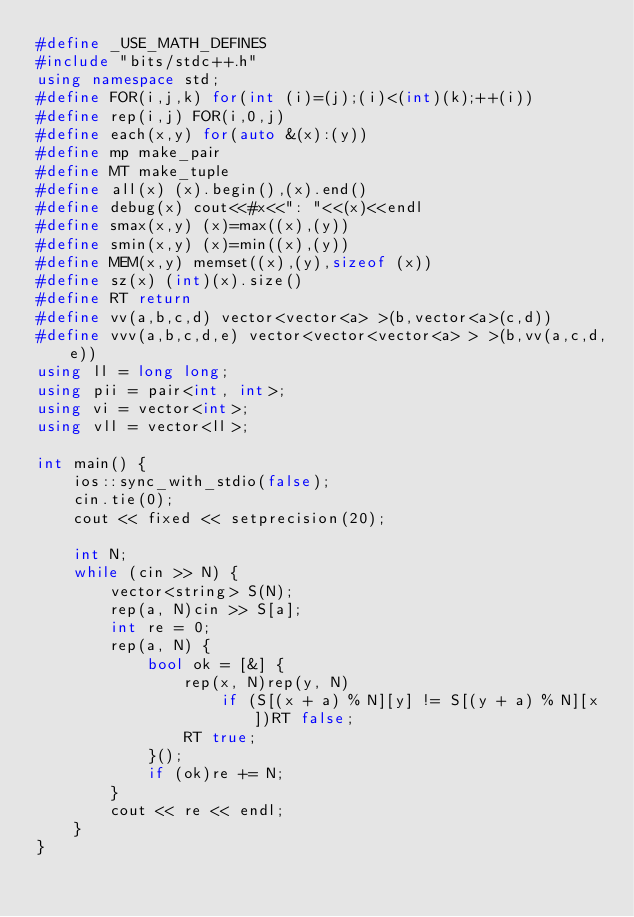Convert code to text. <code><loc_0><loc_0><loc_500><loc_500><_C++_>#define _USE_MATH_DEFINES
#include "bits/stdc++.h"
using namespace std;
#define FOR(i,j,k) for(int (i)=(j);(i)<(int)(k);++(i))
#define rep(i,j) FOR(i,0,j)
#define each(x,y) for(auto &(x):(y))
#define mp make_pair
#define MT make_tuple
#define all(x) (x).begin(),(x).end()
#define debug(x) cout<<#x<<": "<<(x)<<endl
#define smax(x,y) (x)=max((x),(y))
#define smin(x,y) (x)=min((x),(y))
#define MEM(x,y) memset((x),(y),sizeof (x))
#define sz(x) (int)(x).size()
#define RT return
#define vv(a,b,c,d) vector<vector<a> >(b,vector<a>(c,d))
#define vvv(a,b,c,d,e) vector<vector<vector<a> > >(b,vv(a,c,d,e))
using ll = long long;
using pii = pair<int, int>;
using vi = vector<int>;
using vll = vector<ll>;

int main() {
    ios::sync_with_stdio(false);
    cin.tie(0);
    cout << fixed << setprecision(20);

    int N;
    while (cin >> N) {
        vector<string> S(N);
        rep(a, N)cin >> S[a];
        int re = 0;
        rep(a, N) {
            bool ok = [&] {
                rep(x, N)rep(y, N)
                    if (S[(x + a) % N][y] != S[(y + a) % N][x])RT false;
                RT true;
            }();
            if (ok)re += N;
        }
        cout << re << endl;
    }
}</code> 